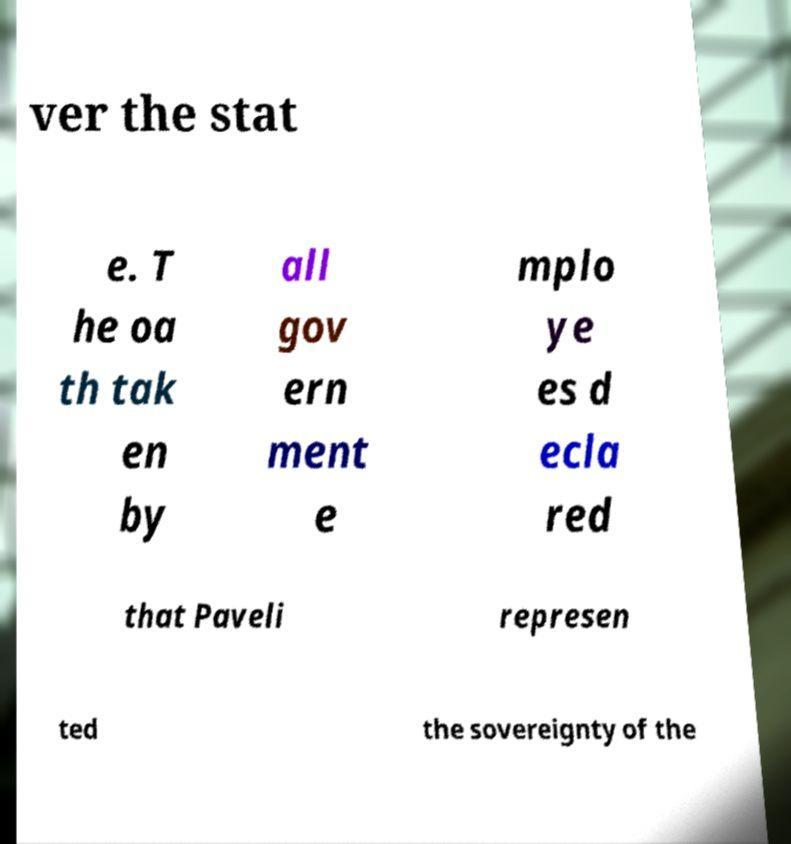Could you extract and type out the text from this image? ver the stat e. T he oa th tak en by all gov ern ment e mplo ye es d ecla red that Paveli represen ted the sovereignty of the 